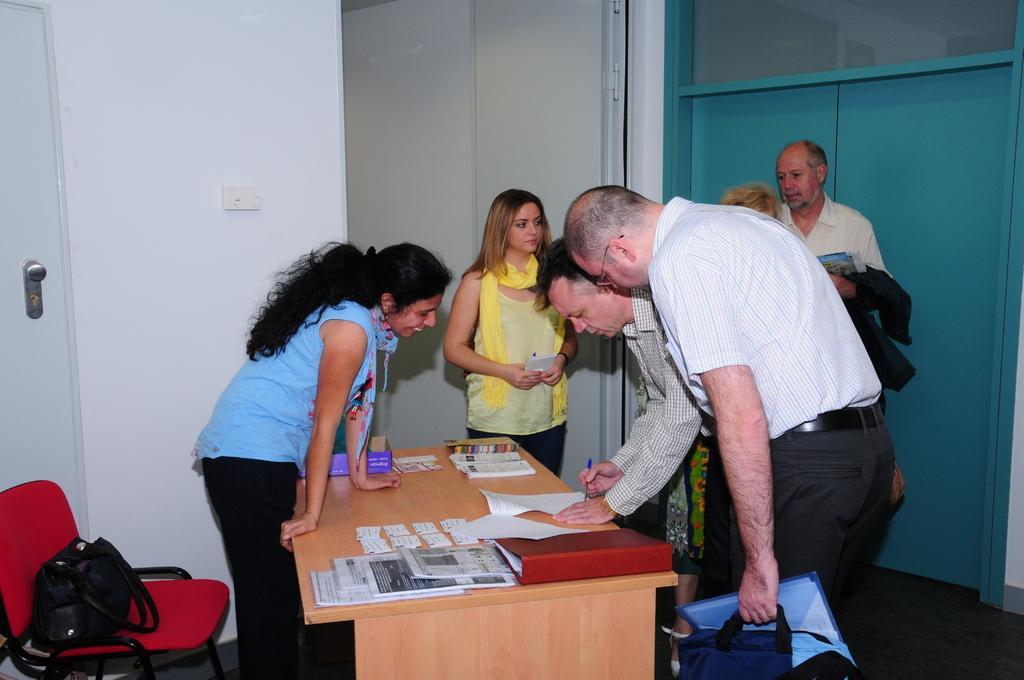Describe this image in one or two sentences. In this picture we can see a group of people standing around the table on which there are some papers, files and there is a chair and a hand bag on it. 